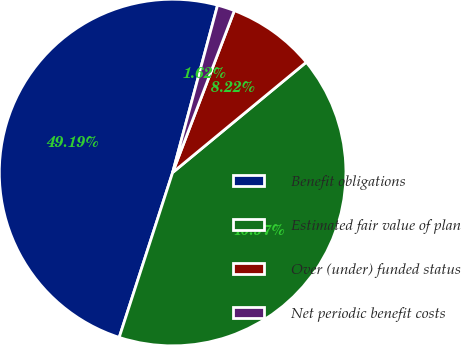<chart> <loc_0><loc_0><loc_500><loc_500><pie_chart><fcel>Benefit obligations<fcel>Estimated fair value of plan<fcel>Over (under) funded status<fcel>Net periodic benefit costs<nl><fcel>49.19%<fcel>40.97%<fcel>8.22%<fcel>1.62%<nl></chart> 